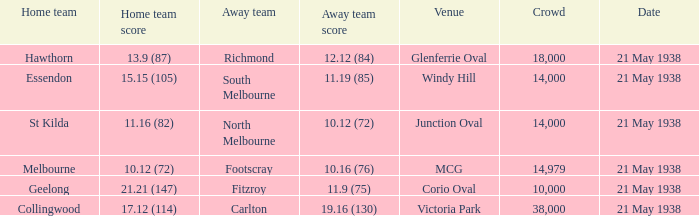Which away side possesses a crowd surpassing 14,000 and has a home team originating from melbourne? Footscray. 